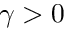Convert formula to latex. <formula><loc_0><loc_0><loc_500><loc_500>\gamma > 0</formula> 